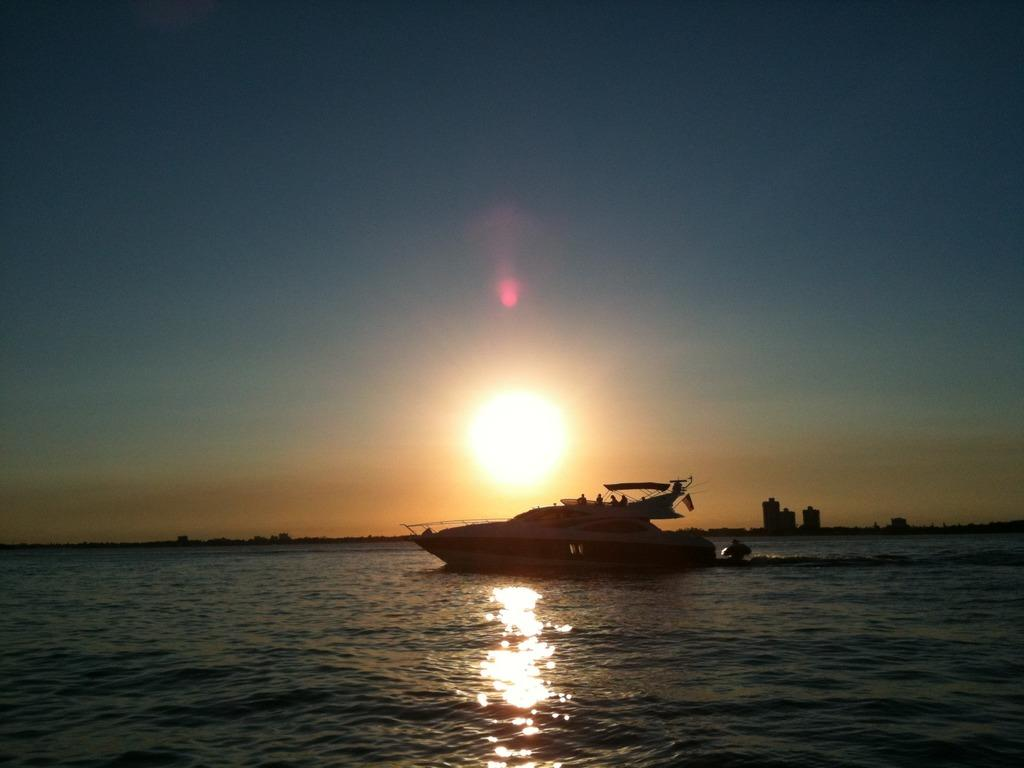What is the main subject of the image? The main subject of the image is a boat. Where is the boat located? The boat is on the water. What can be seen in the background of the image? There are buildings and the sky visible in the background of the image. Can you tell me how many dogs are swimming in the water next to the boat? There are no dogs present in the image; it only features a boat on the water. What type of pleasure can be experienced by the people on the boat? The image does not provide any information about the people on the boat or their experience, so it is impossible to determine the type of pleasure they might be experiencing. 